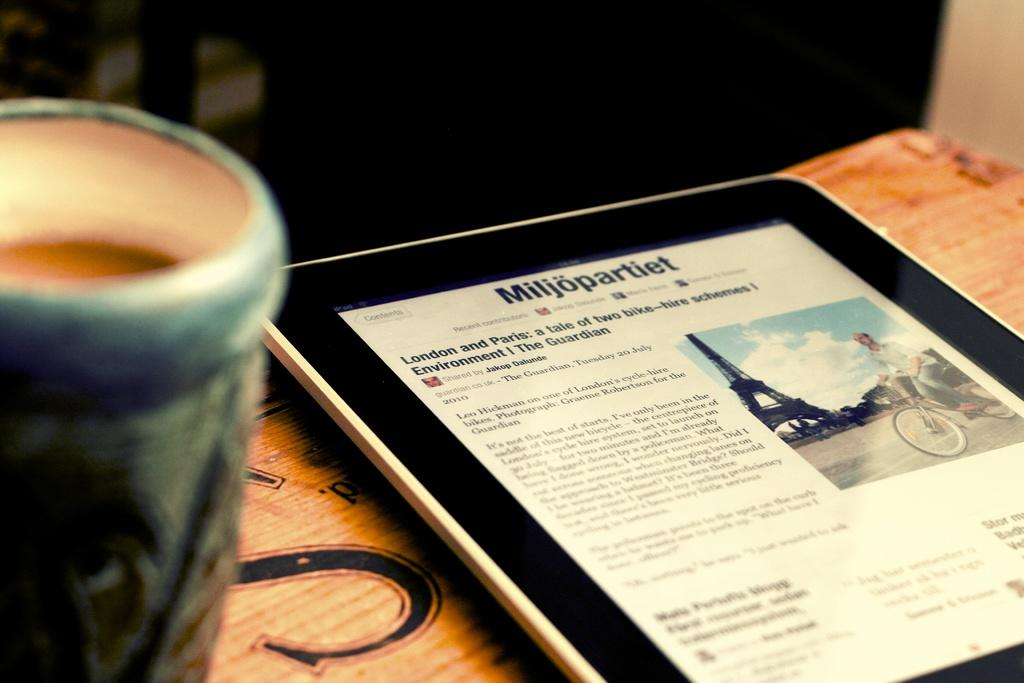Provide a one-sentence caption for the provided image. A tablet displays a news story about bike hire schemes in London and Paris. 